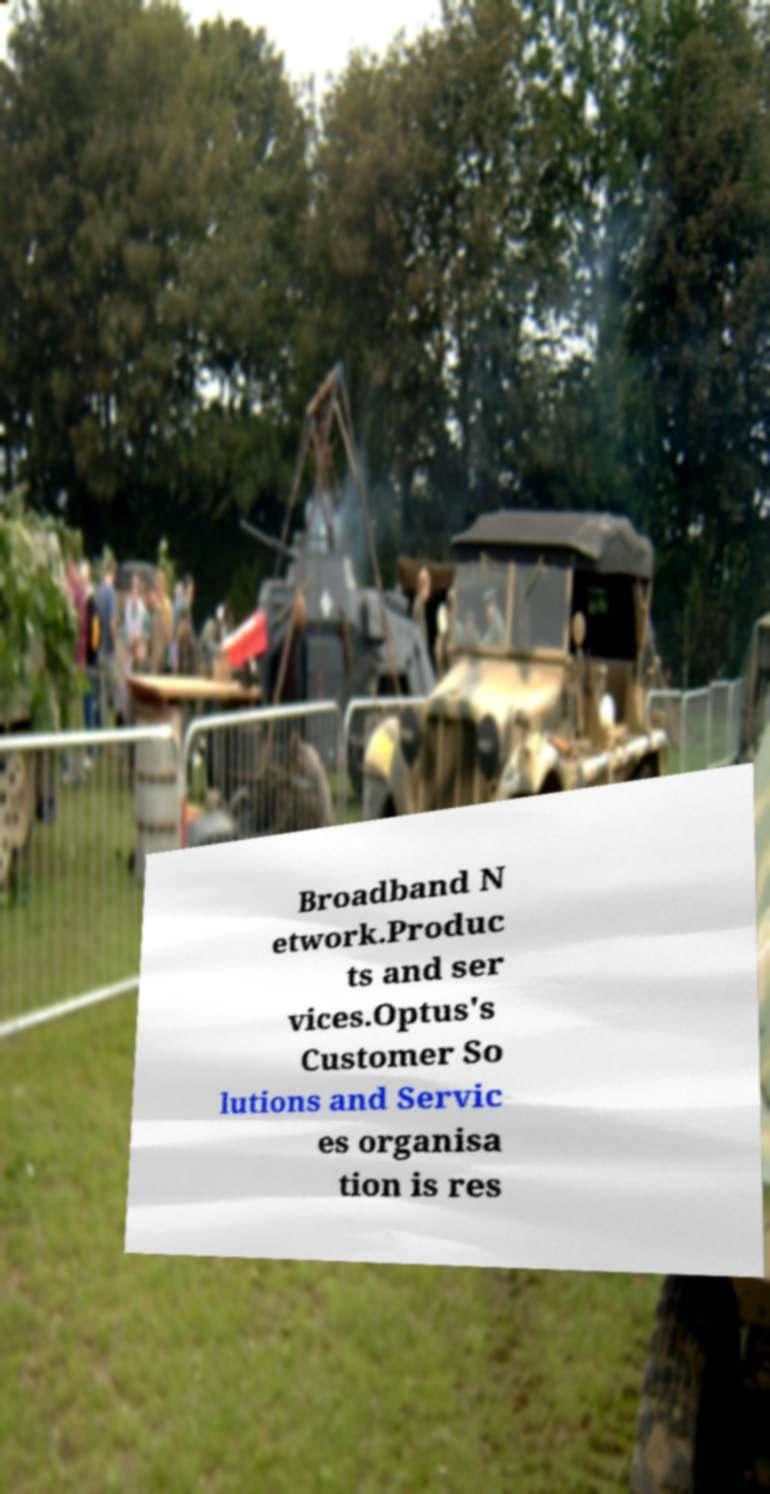Can you read and provide the text displayed in the image?This photo seems to have some interesting text. Can you extract and type it out for me? Broadband N etwork.Produc ts and ser vices.Optus's Customer So lutions and Servic es organisa tion is res 